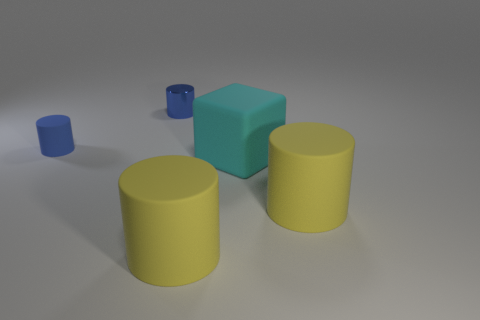The other object that is the same color as the tiny shiny object is what shape?
Keep it short and to the point. Cylinder. What size is the metal cylinder that is the same color as the small rubber object?
Your answer should be very brief. Small. How many other objects are there of the same shape as the big cyan matte thing?
Your response must be concise. 0. There is a cylinder that is left of the metal cylinder; what is its color?
Make the answer very short. Blue. Do the cyan matte block and the blue metallic object have the same size?
Ensure brevity in your answer.  No. What material is the blue thing that is behind the blue object on the left side of the small shiny cylinder?
Keep it short and to the point. Metal. What number of cylinders have the same color as the tiny rubber thing?
Ensure brevity in your answer.  1. Are there any other things that have the same material as the big cube?
Offer a terse response. Yes. Are there fewer blue metallic cylinders in front of the tiny matte object than tiny cyan shiny balls?
Ensure brevity in your answer.  No. There is a tiny cylinder that is in front of the blue metal object that is behind the cyan rubber thing; what is its color?
Your response must be concise. Blue. 